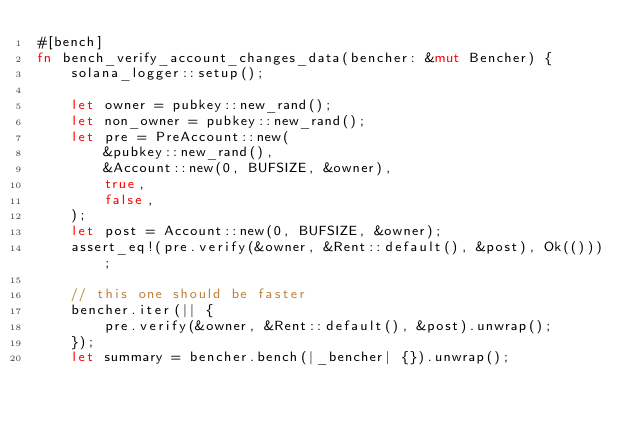Convert code to text. <code><loc_0><loc_0><loc_500><loc_500><_Rust_>#[bench]
fn bench_verify_account_changes_data(bencher: &mut Bencher) {
    solana_logger::setup();

    let owner = pubkey::new_rand();
    let non_owner = pubkey::new_rand();
    let pre = PreAccount::new(
        &pubkey::new_rand(),
        &Account::new(0, BUFSIZE, &owner),
        true,
        false,
    );
    let post = Account::new(0, BUFSIZE, &owner);
    assert_eq!(pre.verify(&owner, &Rent::default(), &post), Ok(()));

    // this one should be faster
    bencher.iter(|| {
        pre.verify(&owner, &Rent::default(), &post).unwrap();
    });
    let summary = bencher.bench(|_bencher| {}).unwrap();</code> 